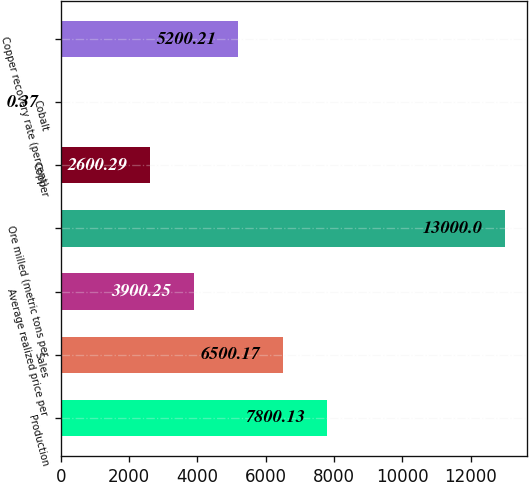<chart> <loc_0><loc_0><loc_500><loc_500><bar_chart><fcel>Production<fcel>Sales<fcel>Average realized price per<fcel>Ore milled (metric tons per<fcel>Copper<fcel>Cobalt<fcel>Copper recovery rate (percent)<nl><fcel>7800.13<fcel>6500.17<fcel>3900.25<fcel>13000<fcel>2600.29<fcel>0.37<fcel>5200.21<nl></chart> 